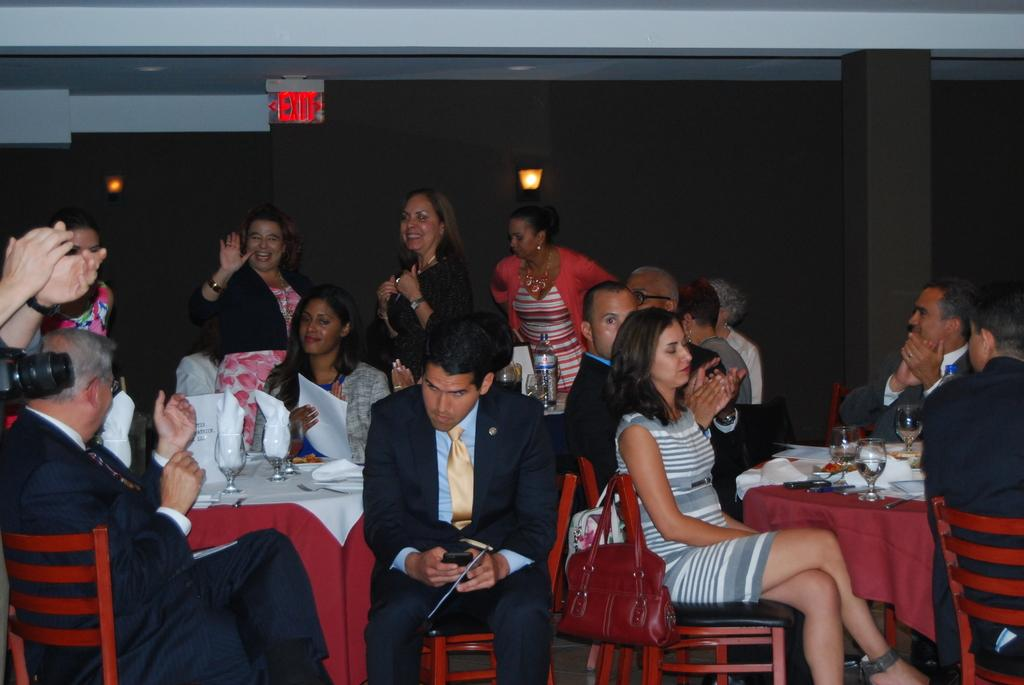<image>
Share a concise interpretation of the image provided. Several people at an event are sitting right under a red EXIT sign. 